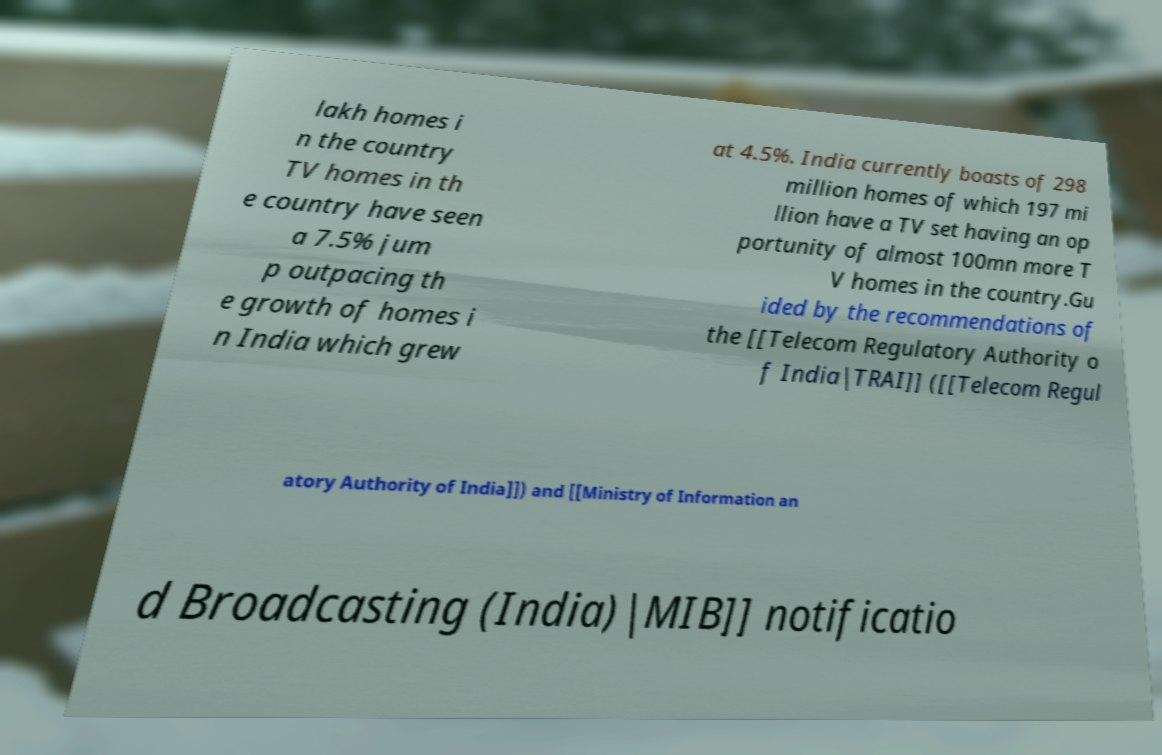There's text embedded in this image that I need extracted. Can you transcribe it verbatim? lakh homes i n the country TV homes in th e country have seen a 7.5% jum p outpacing th e growth of homes i n India which grew at 4.5%. India currently boasts of 298 million homes of which 197 mi llion have a TV set having an op portunity of almost 100mn more T V homes in the country.Gu ided by the recommendations of the [[Telecom Regulatory Authority o f India|TRAI]] ([[Telecom Regul atory Authority of India]]) and [[Ministry of Information an d Broadcasting (India)|MIB]] notificatio 